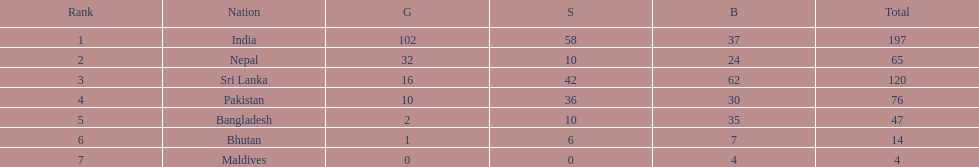What country has won no silver medals? Maldives. 